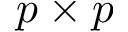<formula> <loc_0><loc_0><loc_500><loc_500>p \times p</formula> 